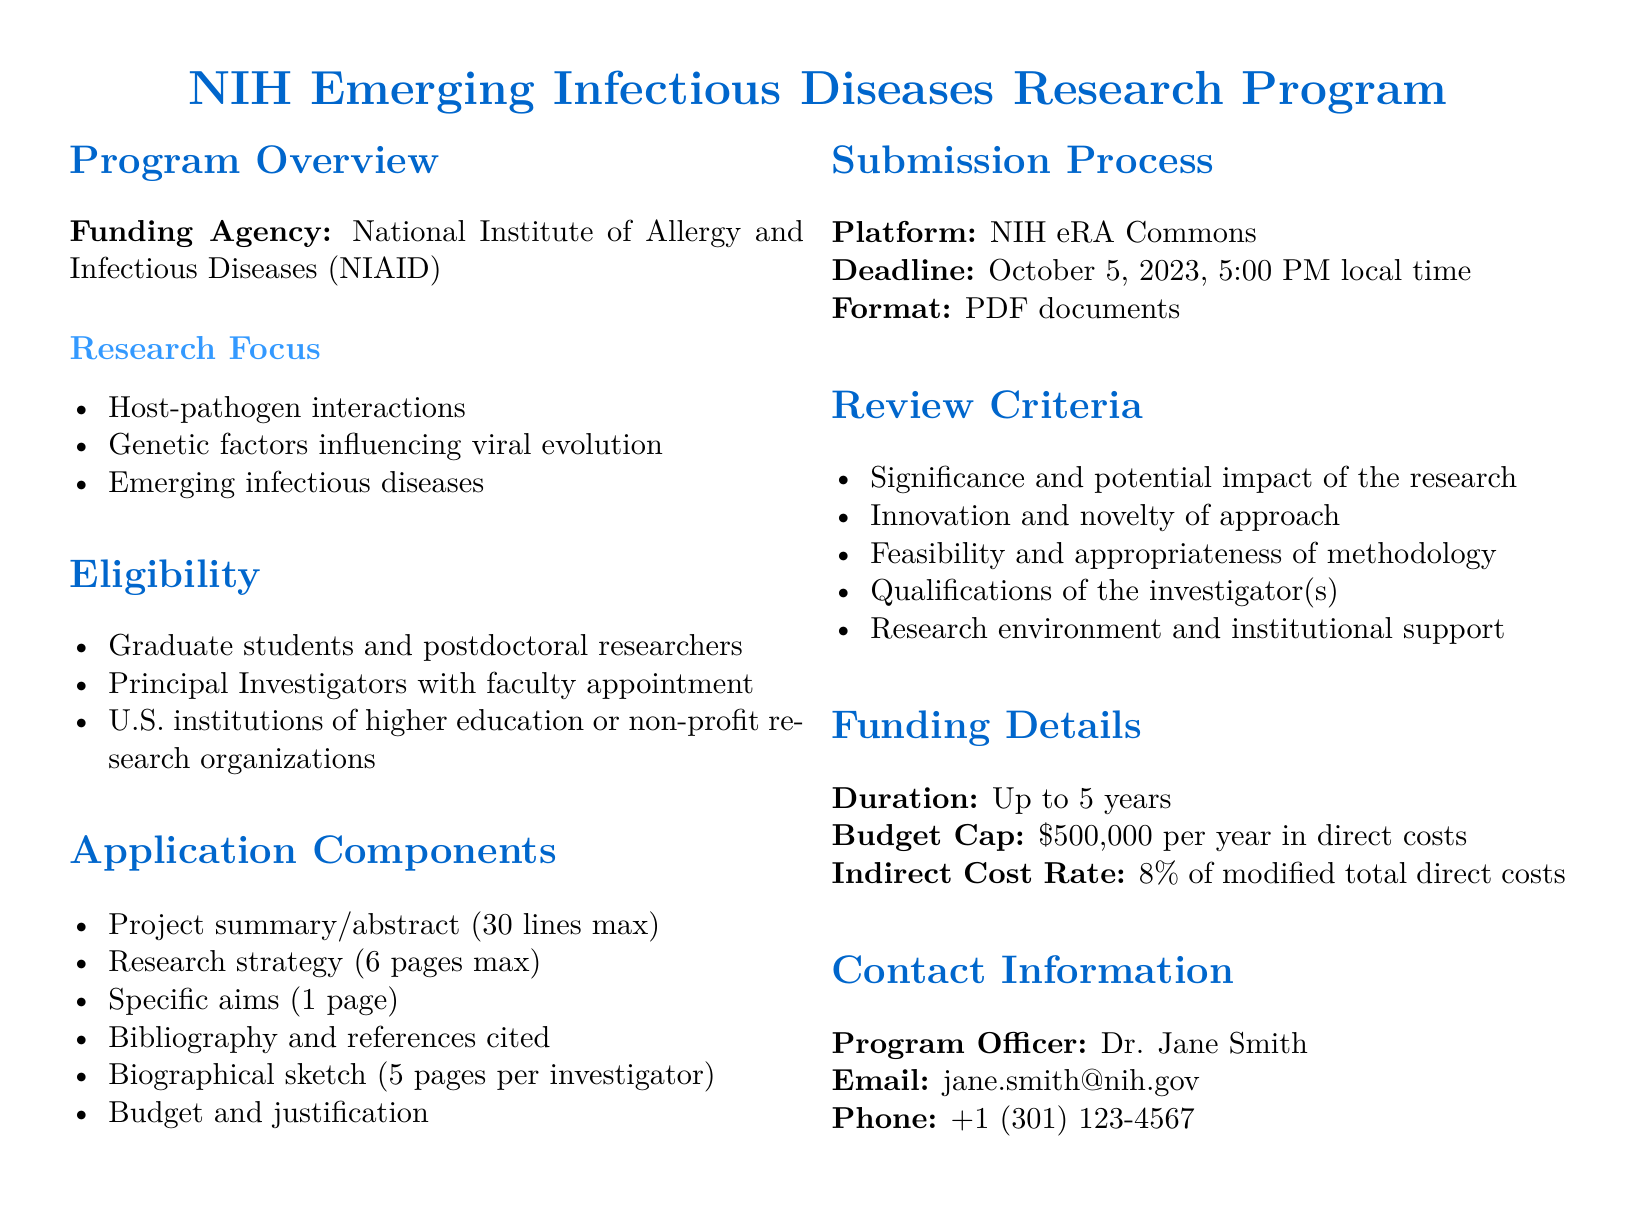What is the funding agency? The funding agency is specified in the "Program Overview" section of the document.
Answer: National Institute of Allergy and Infectious Diseases (NIAID) What is the application deadline? The application deadline is mentioned in the "Submission Process" section of the document.
Answer: October 5, 2023, 5:00 PM local time Who is the program officer? The program officer's name is found in the "Contact Information" section.
Answer: Dr. Jane Smith What is the maximum duration of funding? The maximum duration is stated in the "Funding Details" section.
Answer: Up to 5 years What is the budget cap per year in direct costs? The budget cap for direct costs is indicated in the "Funding Details" section.
Answer: 500,000 dollars What types of researchers are eligible to apply? Eligibility details are provided in the "Eligibility" section, which lists the types of applicants.
Answer: Graduate students and postdoctoral researchers, Principal Investigators with faculty appointment What is one of the review criteria? The review criteria are listed in the "Review Criteria" section, and any one of them can serve as an answer.
Answer: Significance and potential impact of the research What is the indirect cost rate? The indirect cost rate is specified in the "Funding Details" section.
Answer: 8 percent of modified total direct costs What is required for the project summary? The requirements for the project summary are found in the "Application Components" section.
Answer: 30 lines max What is the format for submission? The format for submission is mentioned in the "Submission Process" section of the document.
Answer: PDF documents 